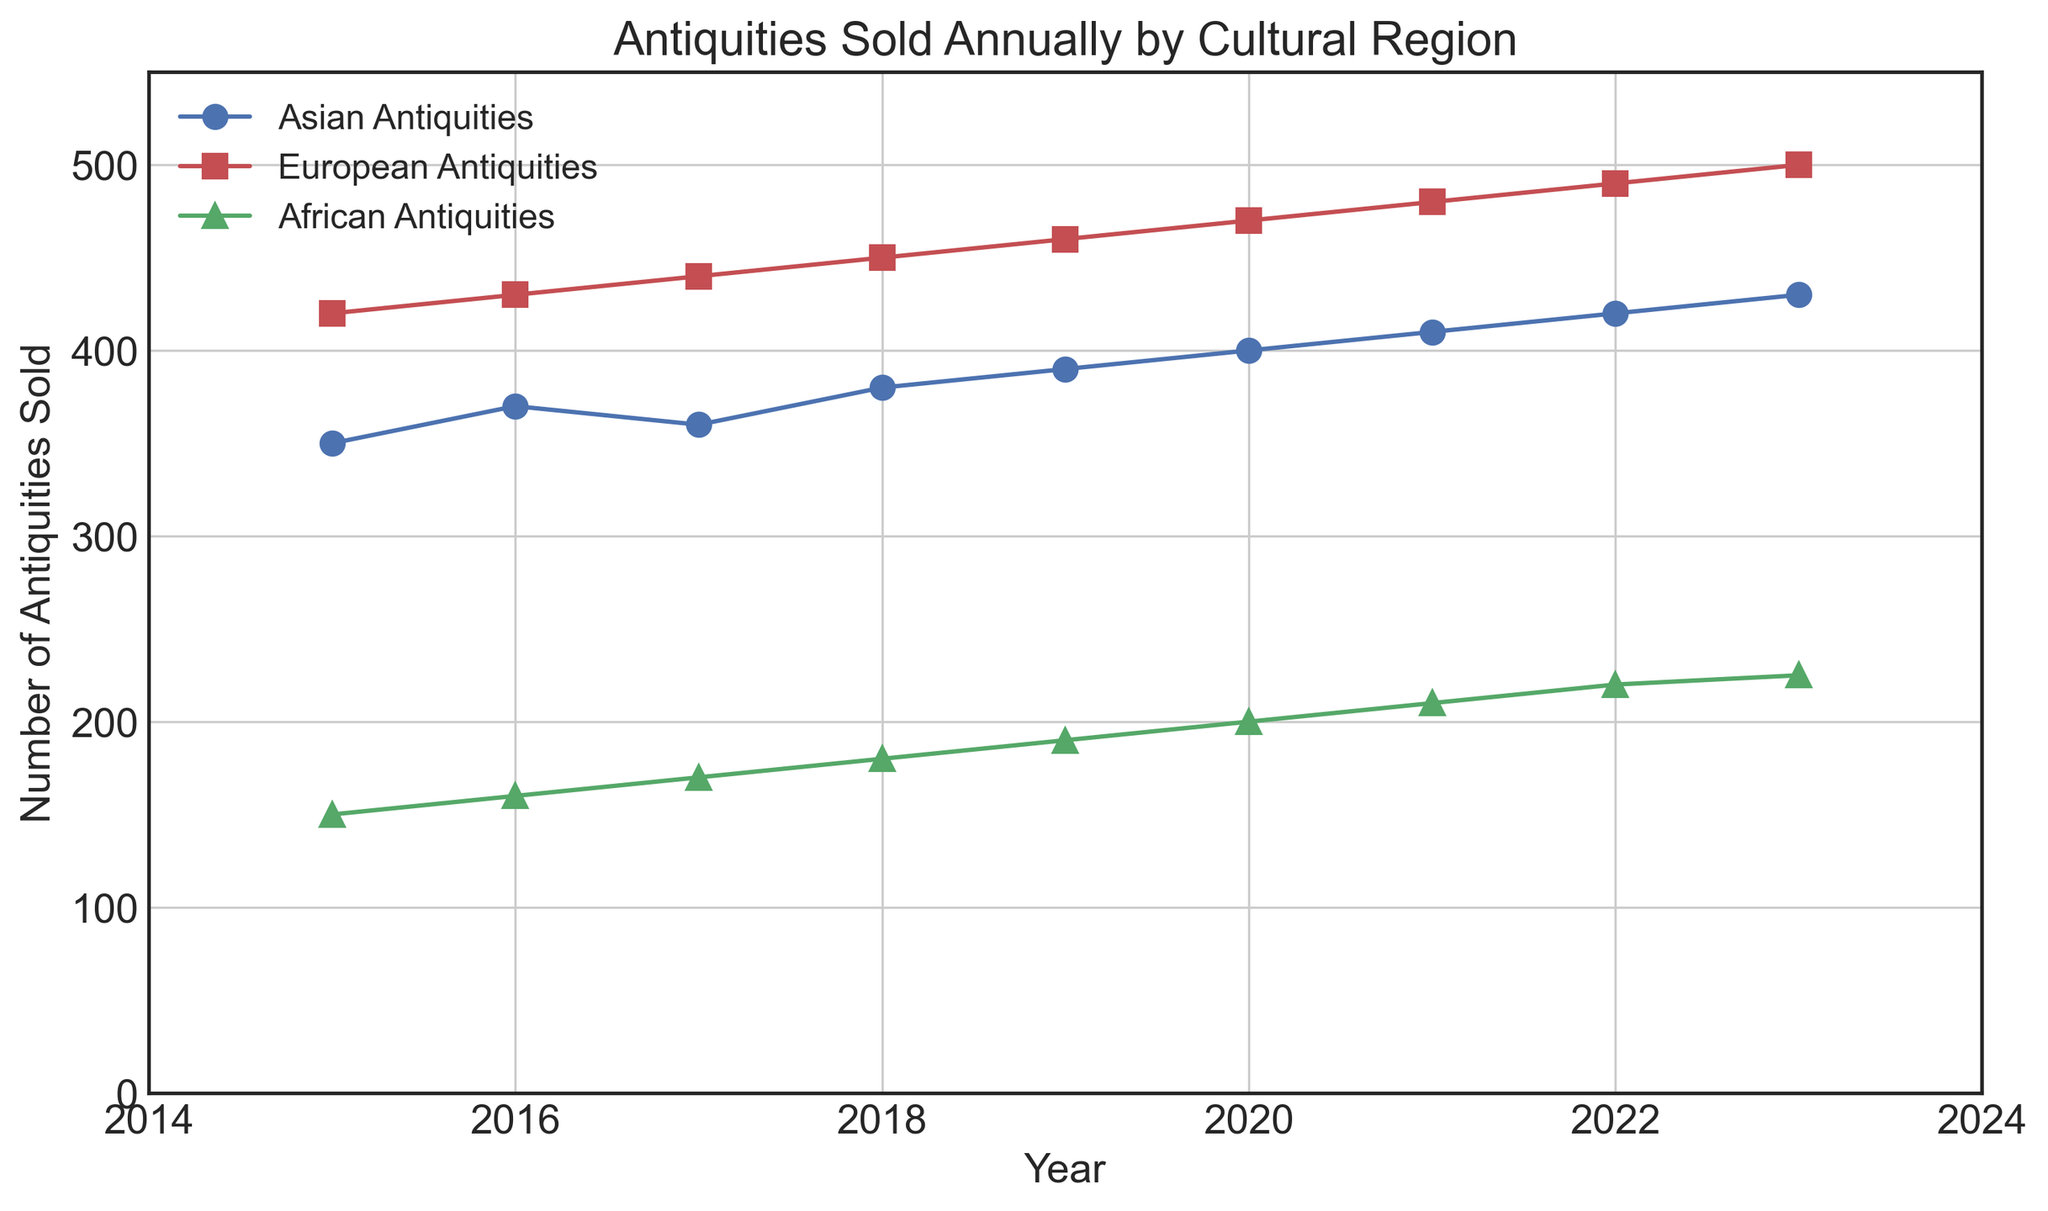Which cultural region had the highest number of antiquities sold in 2023? By looking at the data points for the year 2023, we can compare the three regions. The highest count is for European antiquities at 500.
Answer: European Between 2015 and 2023, which region showed the most consistent increase in antiquities sold? By visually examining the trend lines for each region, European antiquities show a constant upward trend, indicating a consistent increase.
Answer: European What's the difference in the number of Asian antiquities sold between 2015 and 2023? The number of Asian antiquities sold in 2015 is 350, and in 2023 it is 430. The difference is calculated as 430 - 350.
Answer: 80 Which region had the smallest increase in antiquities sold from 2015 to 2023? By comparing the initial and final values for each region, African antiquities increased from 150 to 225, which is the smallest increase of the three.
Answer: African In which year did European antiquities see the largest increase compared to the previous year? By comparing the differences year-on-year visually for European antiquities, the largest increase is between 2015 and 2016, where it increases by 10 (420 to 430).
Answer: 2016 Which cultural region had the lowest number of antiquities sold in 2020? By referring to the data for the year 2020, African antiquities had the lowest count at 200.
Answer: African What's the average number of African antiquities sold per year from 2015 to 2023? The counts are {150, 160, 170, 180, 190, 200, 210, 220, 225}. The average is calculated by summing these values and dividing by 9 (since there are nine years). The sum is 1605, so the average is 1605 / 9.
Answer: 178.33 Which year saw the highest total number of antiquities sold across all regions? By summing the counts for all regions year by year, the highest total is in 2023: 430 (Asian) + 500 (European) + 225 (African) = 1155.
Answer: 2023 If the trend continued, how many African antiquities would you expect to be sold in 2024? By identifying the yearly increase trend for African antiquities which is approximately 10 from 2015 to 2023, adding 10 to the count in 2023 gives an estimate for 2024.
Answer: 235 